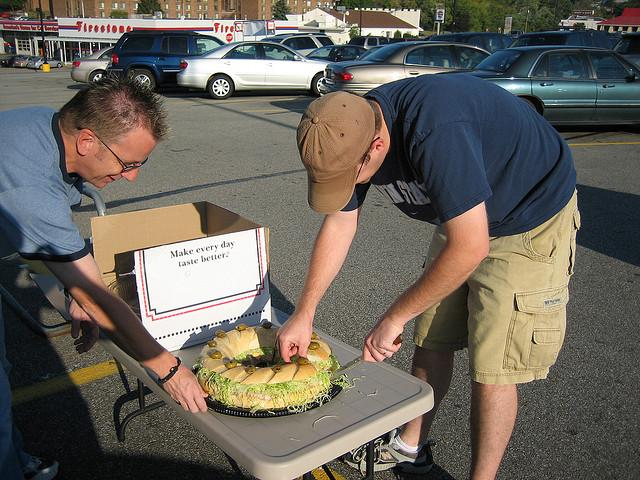How many days ago was this cake made?

Choices:
A) one day
B) today
C) three days
D) two days today 